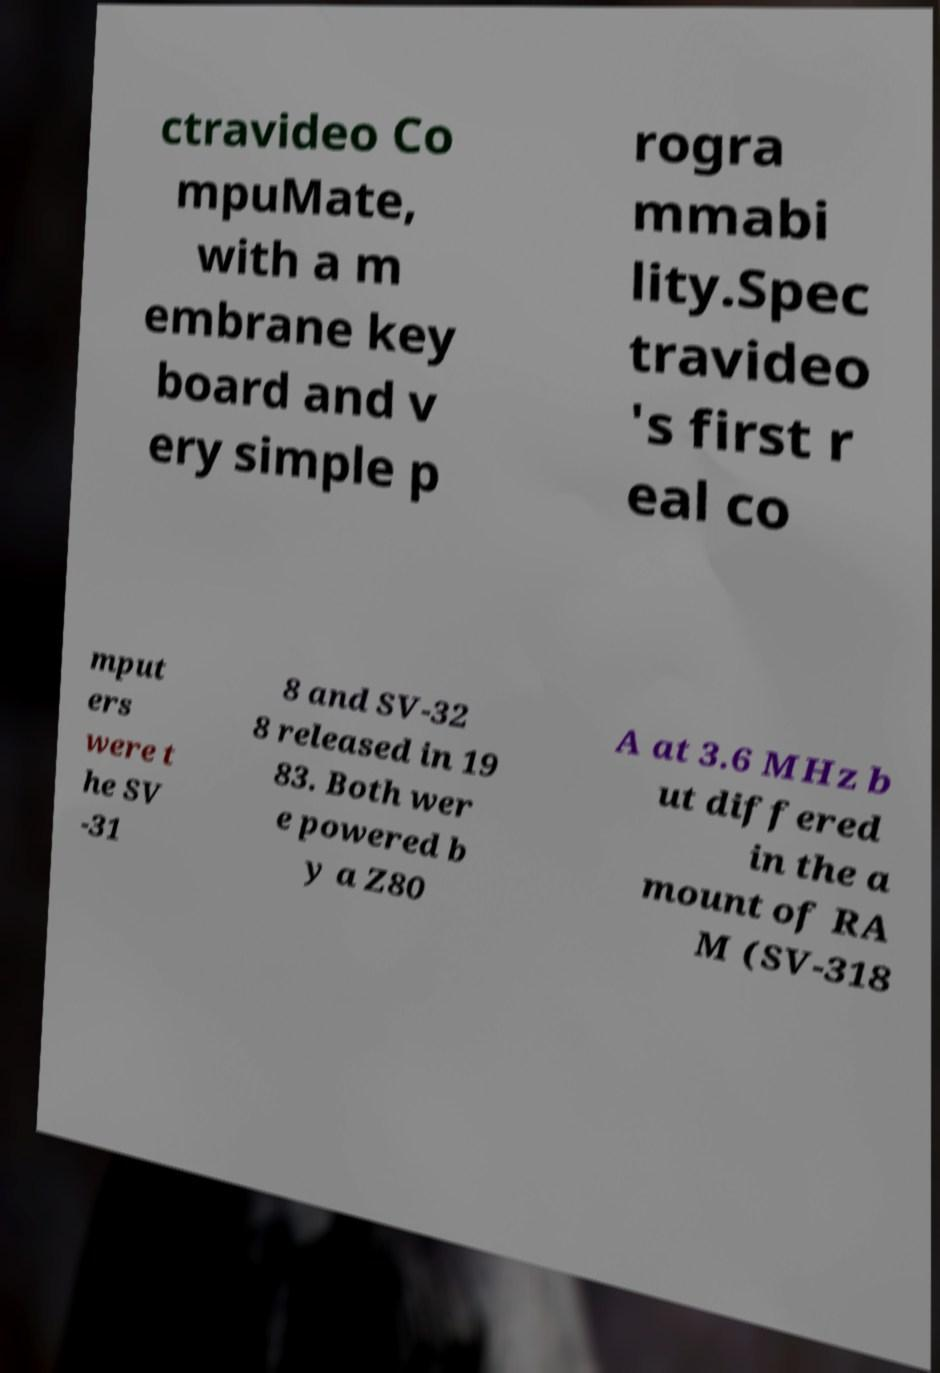Can you read and provide the text displayed in the image?This photo seems to have some interesting text. Can you extract and type it out for me? ctravideo Co mpuMate, with a m embrane key board and v ery simple p rogra mmabi lity.Spec travideo 's first r eal co mput ers were t he SV -31 8 and SV-32 8 released in 19 83. Both wer e powered b y a Z80 A at 3.6 MHz b ut differed in the a mount of RA M (SV-318 